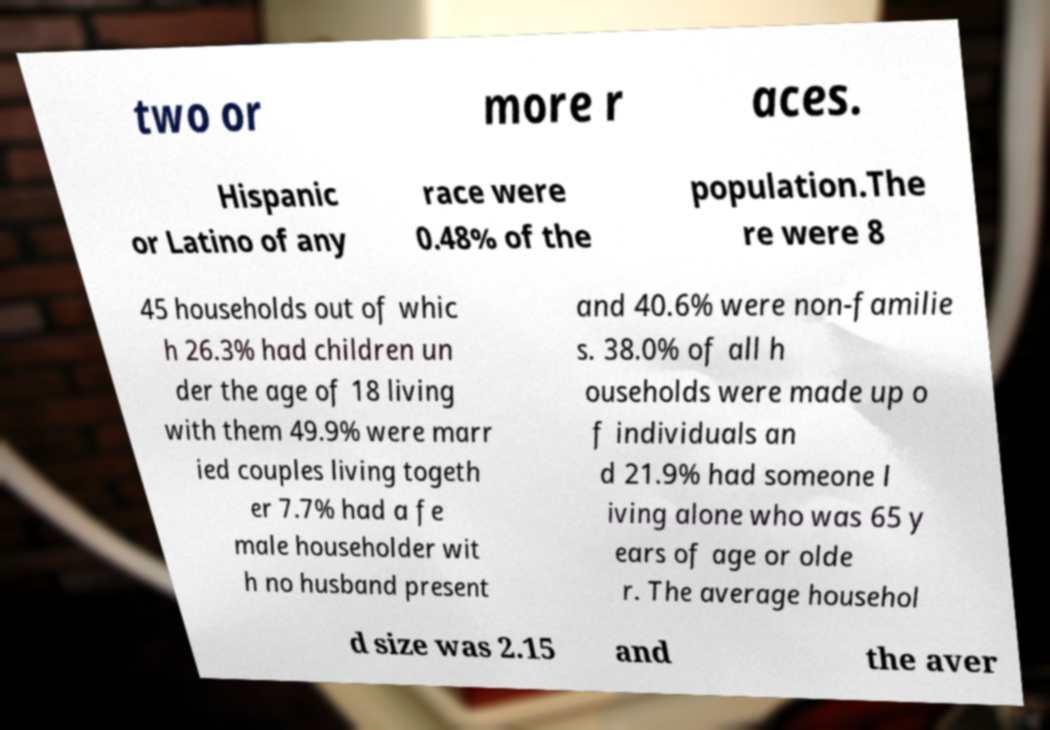I need the written content from this picture converted into text. Can you do that? two or more r aces. Hispanic or Latino of any race were 0.48% of the population.The re were 8 45 households out of whic h 26.3% had children un der the age of 18 living with them 49.9% were marr ied couples living togeth er 7.7% had a fe male householder wit h no husband present and 40.6% were non-familie s. 38.0% of all h ouseholds were made up o f individuals an d 21.9% had someone l iving alone who was 65 y ears of age or olde r. The average househol d size was 2.15 and the aver 